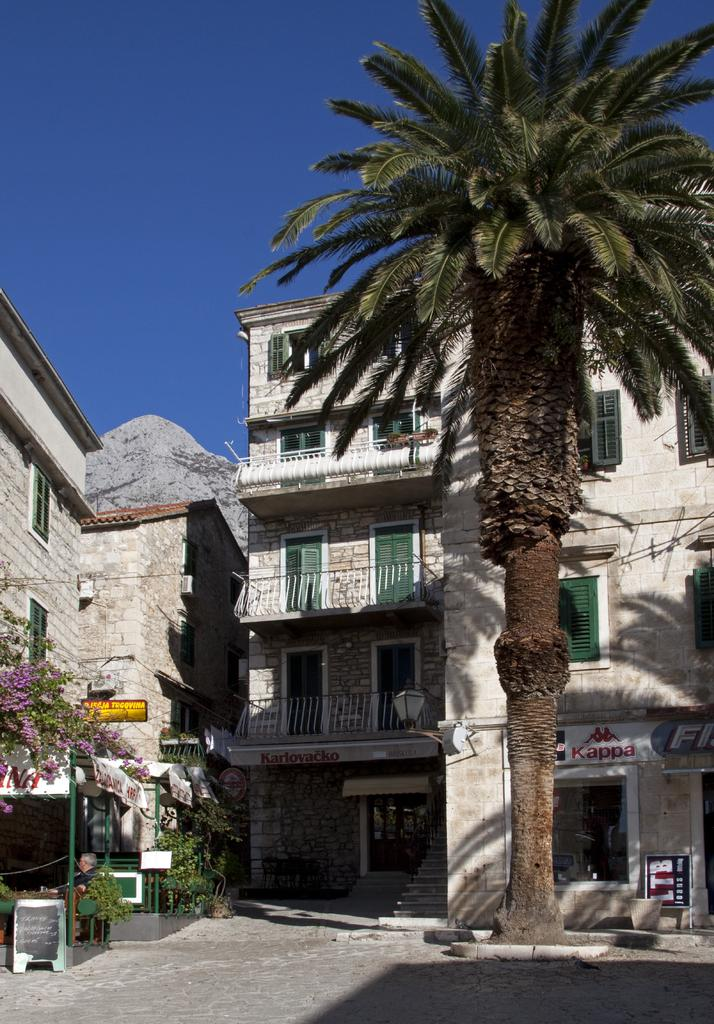<image>
Offer a succinct explanation of the picture presented. A building with a palm tree in front of it with a sign for LTB jeans. 